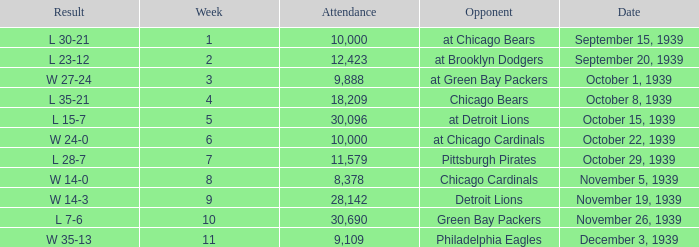What sum of Attendance has a Week smaller than 10, and a Result of l 30-21? 10000.0. 